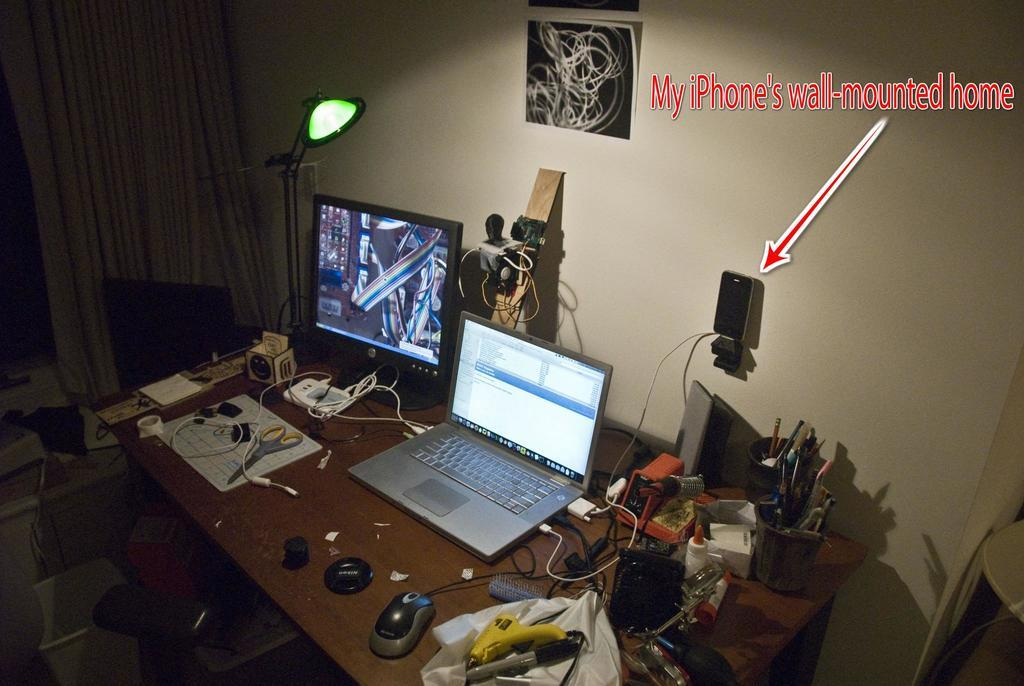<image>
Write a terse but informative summary of the picture. a home office set up with words IPhone's wall-mounted home 